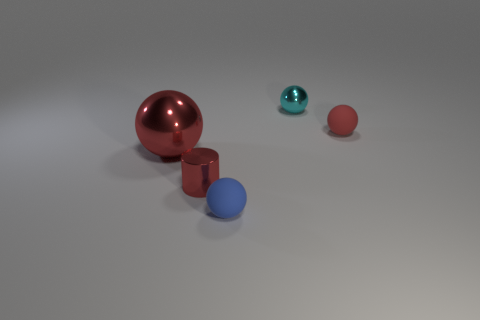Add 2 tiny cyan balls. How many objects exist? 7 Subtract all balls. How many objects are left? 1 Add 5 large red objects. How many large red objects are left? 6 Add 3 small blue rubber spheres. How many small blue rubber spheres exist? 4 Subtract 1 cyan spheres. How many objects are left? 4 Subtract all yellow metallic balls. Subtract all red rubber spheres. How many objects are left? 4 